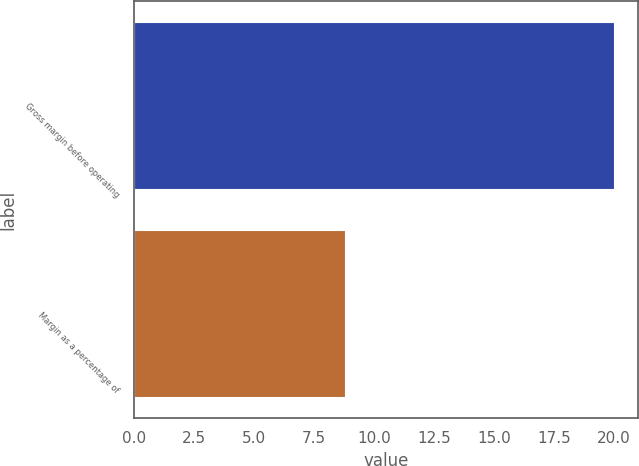Convert chart to OTSL. <chart><loc_0><loc_0><loc_500><loc_500><bar_chart><fcel>Gross margin before operating<fcel>Margin as a percentage of<nl><fcel>20<fcel>8.8<nl></chart> 